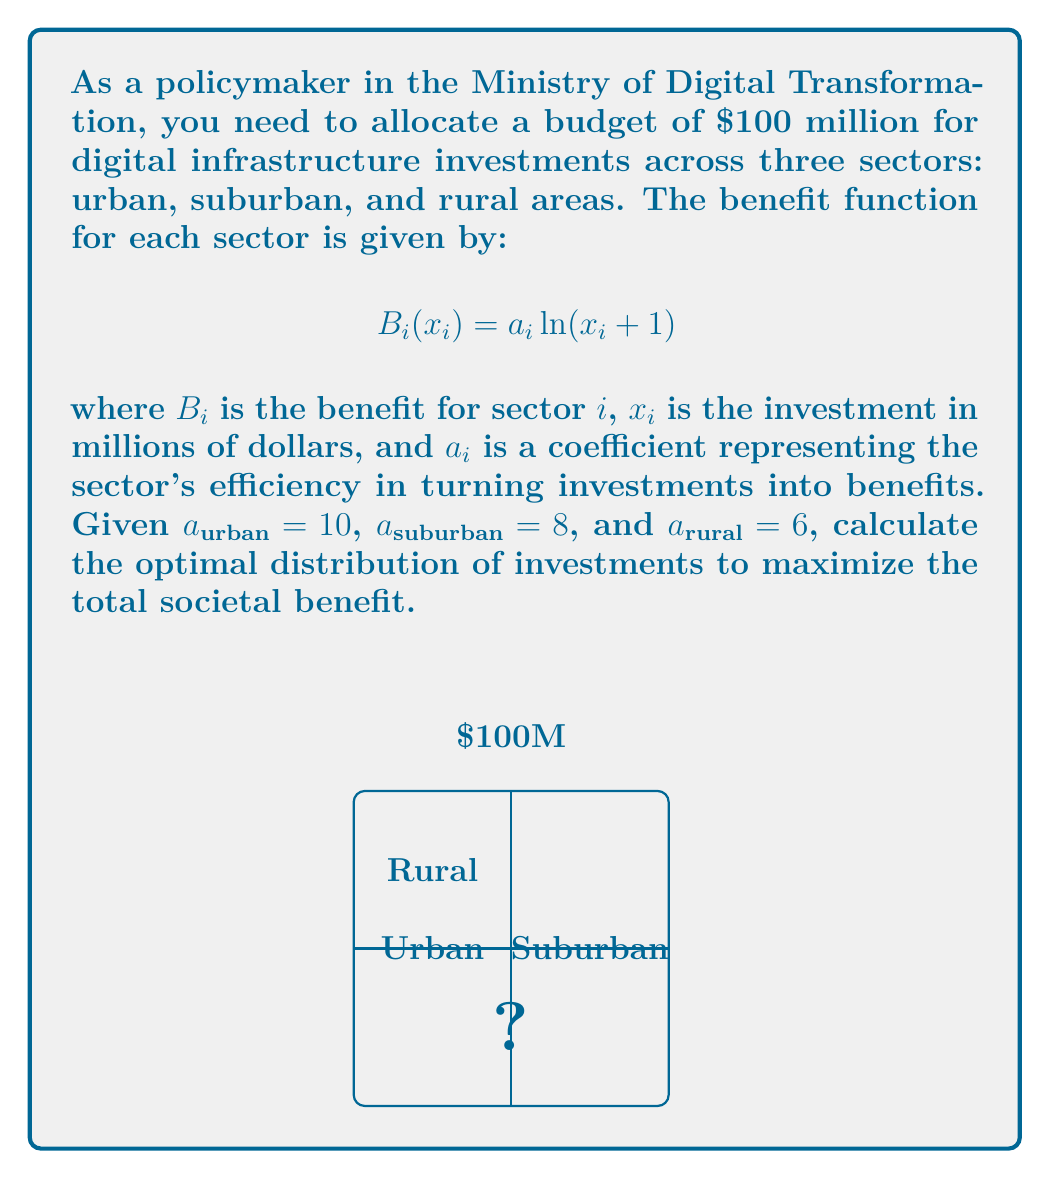Show me your answer to this math problem. To solve this problem, we'll use the method of Lagrange multipliers to maximize the total benefit subject to the budget constraint. Let's follow these steps:

1) Define the total benefit function:
   $$B_{total} = 10\ln(x_{urban} + 1) + 8\ln(x_{suburban} + 1) + 6\ln(x_{rural} + 1)$$

2) Set up the constraint:
   $$x_{urban} + x_{suburban} + x_{rural} = 100$$

3) Form the Lagrangian function:
   $$L = 10\ln(x_{urban} + 1) + 8\ln(x_{suburban} + 1) + 6\ln(x_{rural} + 1) - \lambda(x_{urban} + x_{suburban} + x_{rural} - 100)$$

4) Take partial derivatives and set them equal to zero:
   $$\frac{\partial L}{\partial x_{urban}} = \frac{10}{x_{urban} + 1} - \lambda = 0$$
   $$\frac{\partial L}{\partial x_{suburban}} = \frac{8}{x_{suburban} + 1} - \lambda = 0$$
   $$\frac{\partial L}{\partial x_{rural}} = \frac{6}{x_{rural} + 1} - \lambda = 0$$

5) From these equations, we can deduce:
   $$\frac{10}{x_{urban} + 1} = \frac{8}{x_{suburban} + 1} = \frac{6}{x_{rural} + 1} = \lambda$$

6) This implies:
   $$x_{urban} + 1 = \frac{10}{\lambda}, x_{suburban} + 1 = \frac{8}{\lambda}, x_{rural} + 1 = \frac{6}{\lambda}$$

7) Substituting into the constraint equation:
   $$(\frac{10}{\lambda} - 1) + (\frac{8}{\lambda} - 1) + (\frac{6}{\lambda} - 1) = 100$$
   $$\frac{24}{\lambda} - 3 = 100$$
   $$\frac{24}{\lambda} = 103$$
   $$\lambda = \frac{24}{103}$$

8) Now we can solve for the optimal investments:
   $$x_{urban} = \frac{10}{\lambda} - 1 = \frac{10 \cdot 103}{24} - 1 \approx 41.92$$
   $$x_{suburban} = \frac{8}{\lambda} - 1 = \frac{8 \cdot 103}{24} - 1 \approx 33.33$$
   $$x_{rural} = \frac{6}{\lambda} - 1 = \frac{6 \cdot 103}{24} - 1 \approx 24.75$$

Therefore, the optimal distribution of investments is approximately $41.92 million for urban areas, $33.33 million for suburban areas, and $24.75 million for rural areas.
Answer: Urban: $41.92M, Suburban: $33.33M, Rural: $24.75M 